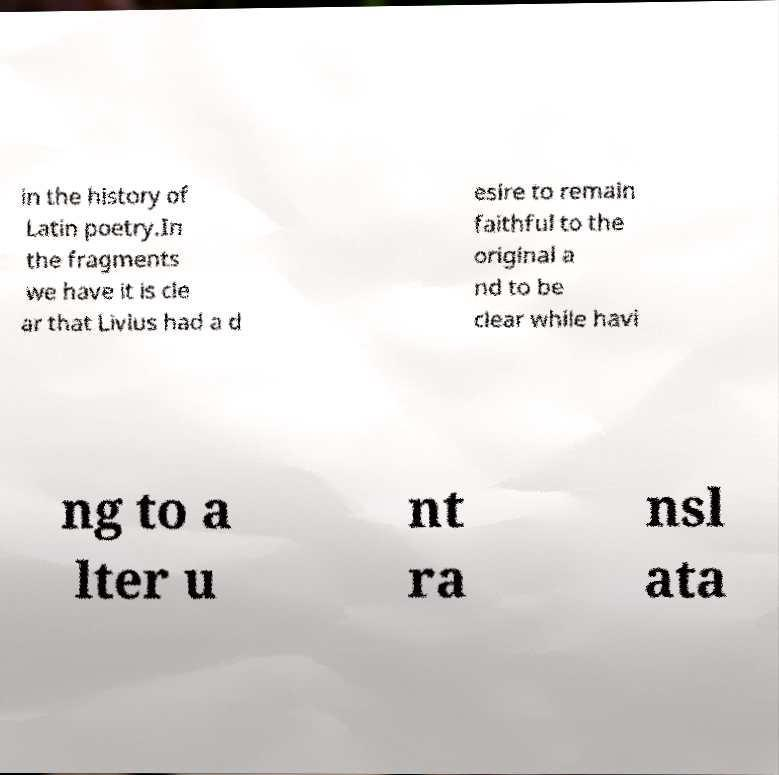Can you accurately transcribe the text from the provided image for me? in the history of Latin poetry.In the fragments we have it is cle ar that Livius had a d esire to remain faithful to the original a nd to be clear while havi ng to a lter u nt ra nsl ata 